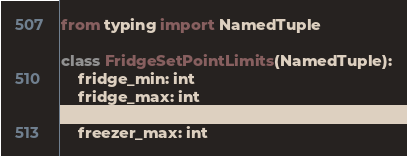Convert code to text. <code><loc_0><loc_0><loc_500><loc_500><_Python_>from typing import NamedTuple

class FridgeSetPointLimits(NamedTuple):
    fridge_min: int
    fridge_max: int
    freezer_min: int
    freezer_max: int</code> 